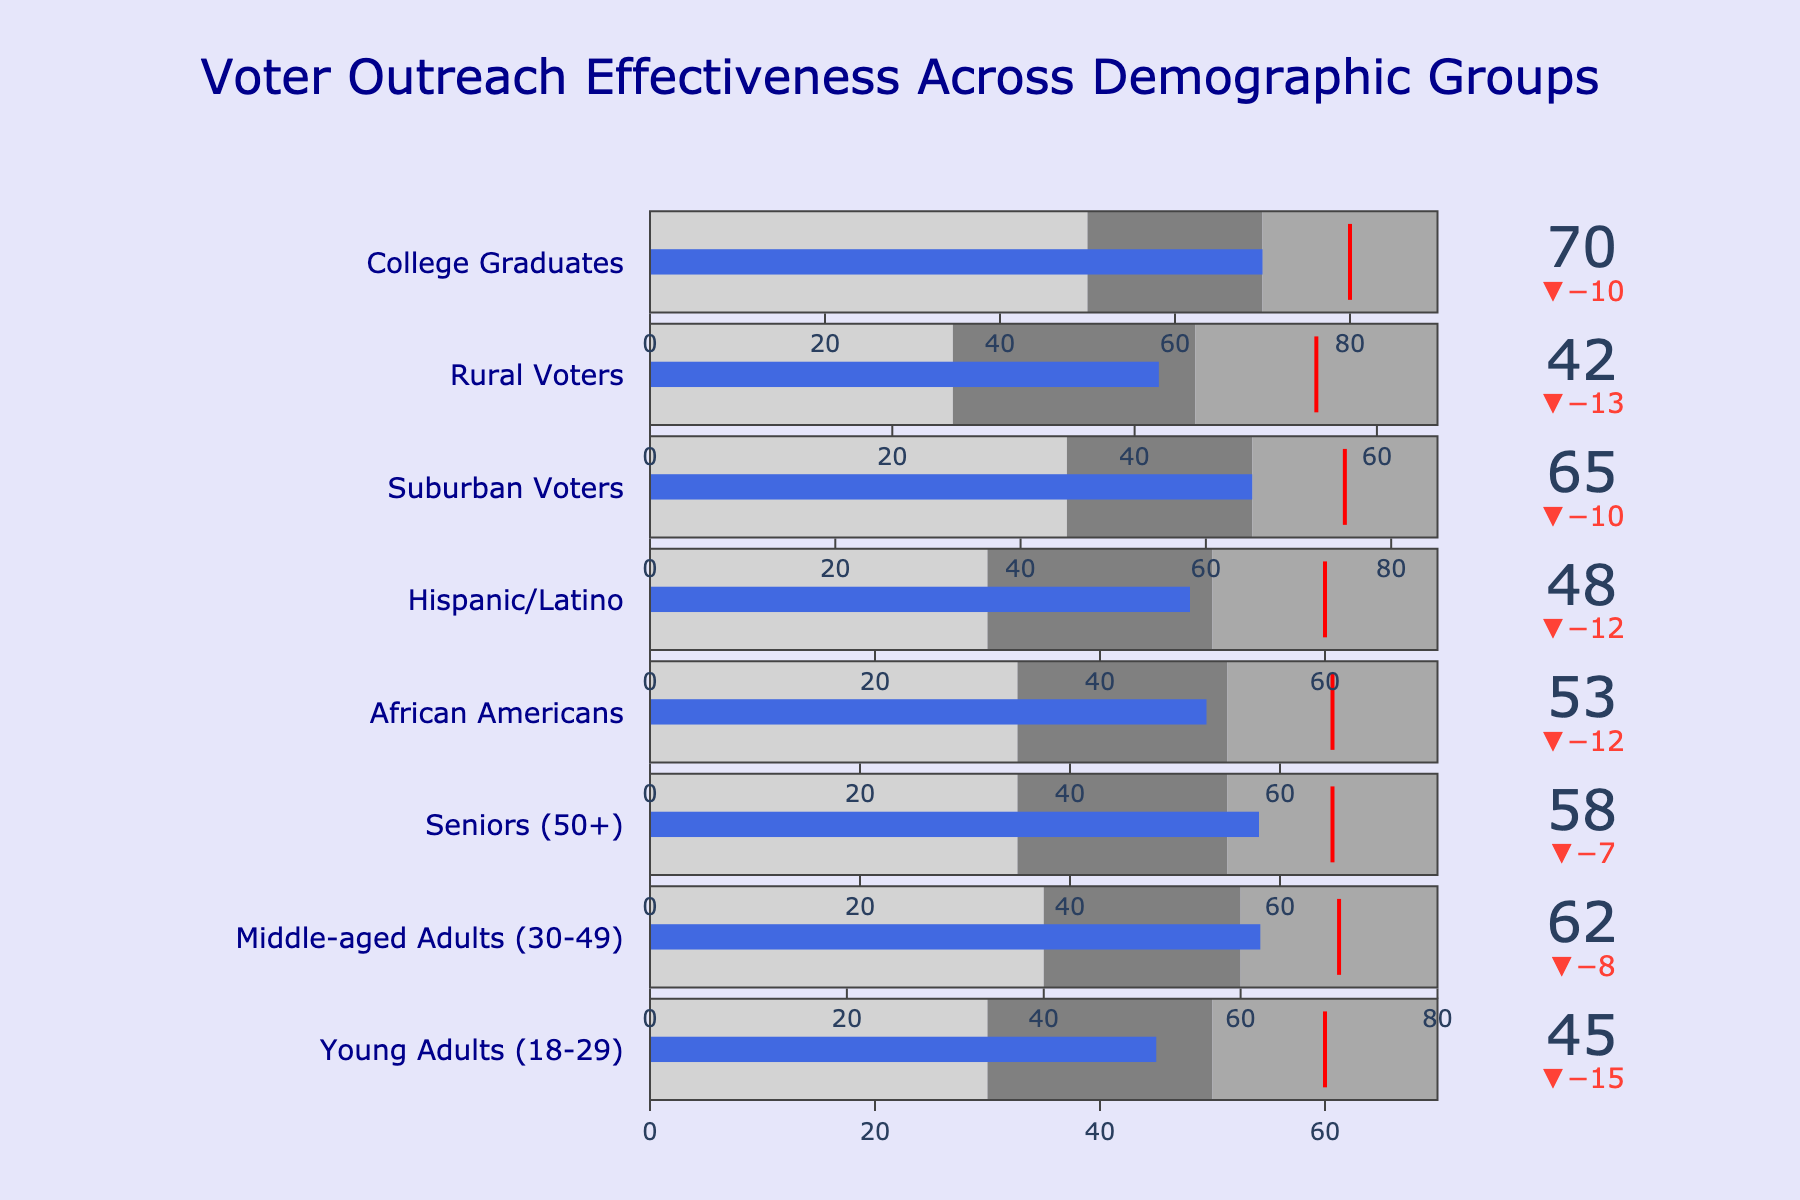What is the title of the figure? The title is usually displayed at the top of the figure and summarizes the content. Here, it reads “Voter Outreach Effectiveness Across Demographic Groups.”
Answer: Voter Outreach Effectiveness Across Demographic Groups How many demographic groups are shown in the chart? The chart displays each category separately. Counting the categories, we find there are eight groups.
Answer: 8 Which demographic group has the highest actual value? Looking at the 'Actual' values given in the chart bullets, the highest value is observed in “College Graduates” with a value of 70.
Answer: College Graduates What is the color of the bar representing the actual value in the bullet charts? By visually observing the color of the actual value bars in the bullet charts, they are shown in royal blue.
Answer: Royal blue Which group falls short of their target by the largest margin? To determine this, subtract the actual value from the target for each group. The largest negative difference is for "Young Adults (18-29)" with (45 - 60 = -15).
Answer: Young Adults (18-29) Which groups exceeded their target values? Check the actual values against the target values. "College Graduates" (70 > 80) and "Suburban Voters" (65 > 75) both exceed their target values.
Answer: College Graduates, Suburban Voters How does the actual value for "Rural Voters" compare to "Seniors (50+)"? Comparing actual values, Rural Voters have 42 while Seniors (50+) have 58. Therefore, Seniors have a higher actual value.
Answer: Seniors (50+) How close is the actual value for "Middle-aged Adults (30-49)" to their target? Subtract the actual value from the target for "Middle-aged Adults (30-49)," which gives 62 - 70 = -8, indicating they are 8 points short.
Answer: -8 What range colors are used to distinguish performance segments and what do they represent? By observing the colors in the bullet charts: light gray indicates the lowest range (underperforming), gray indicates the middle range, and dark gray indicates the highest range (best performance).
Answer: Light gray, gray, dark gray What is the average actual value across all groups? To find the average, sum the actual values and divide by the number of groups: (45 + 62 + 58 + 53 + 48 + 65 + 42 + 70) / 8 = 55.375.
Answer: 55.375 